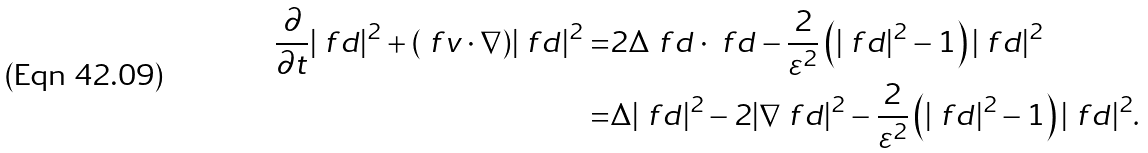Convert formula to latex. <formula><loc_0><loc_0><loc_500><loc_500>\frac { \partial } { \partial t } | \ f d | ^ { 2 } + ( \ f v \cdot \nabla ) | \ f d | ^ { 2 } = & 2 \Delta \ f d \cdot \ f d - \frac { 2 } { \varepsilon ^ { 2 } } \left ( | \ f d | ^ { 2 } - 1 \right ) | \ f d | ^ { 2 } \\ = & \Delta | \ f d | ^ { 2 } - 2 | \nabla \ f d | ^ { 2 } - \frac { 2 } { \varepsilon ^ { 2 } } \left ( | \ f d | ^ { 2 } - 1 \right ) | \ f d | ^ { 2 } .</formula> 